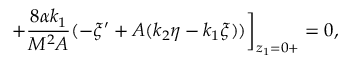<formula> <loc_0><loc_0><loc_500><loc_500>+ \frac { 8 \alpha k _ { 1 } } { M ^ { 2 } A } ( - \xi ^ { \prime } + A ( k _ { 2 } \eta - k _ { 1 } \xi ) ) \Big ] _ { z _ { 1 } = 0 + } = 0 ,</formula> 